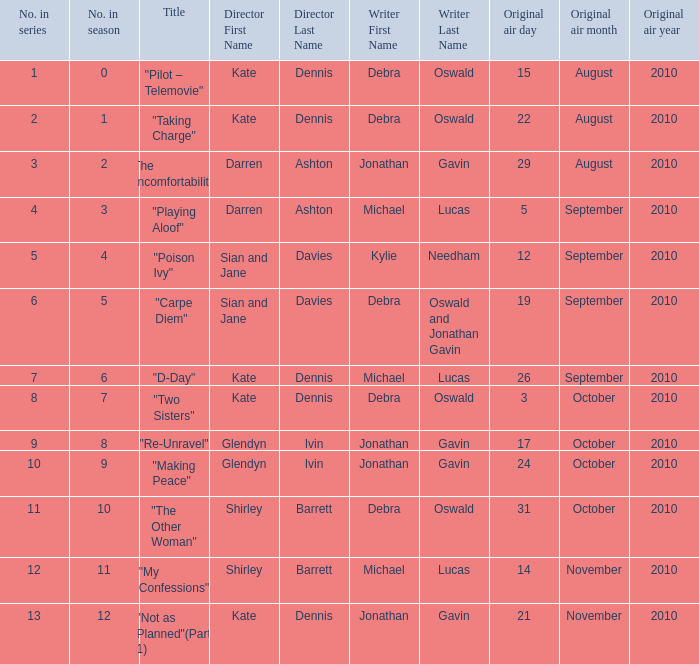When did "My Confessions" first air? 14November2010. 